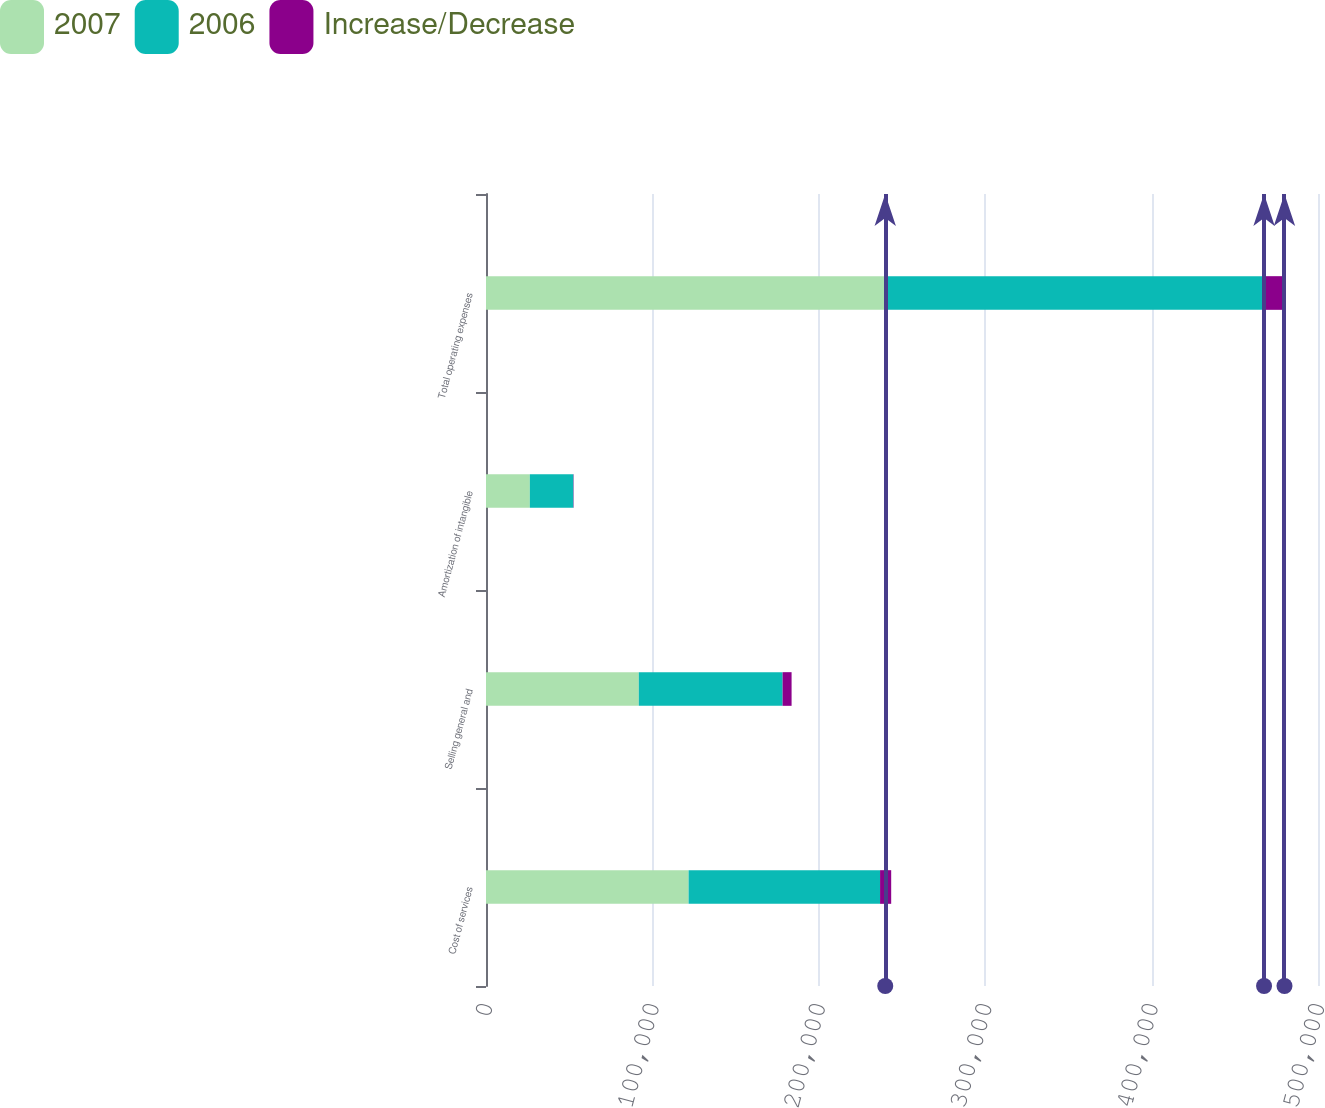Convert chart to OTSL. <chart><loc_0><loc_0><loc_500><loc_500><stacked_bar_chart><ecel><fcel>Cost of services<fcel>Selling general and<fcel>Amortization of intangible<fcel>Total operating expenses<nl><fcel>2007<fcel>121752<fcel>91822<fcel>26353<fcel>239927<nl><fcel>2006<fcel>115068<fcel>86425<fcel>26156<fcel>227649<nl><fcel>Increase/Decrease<fcel>6684<fcel>5397<fcel>197<fcel>12278<nl></chart> 